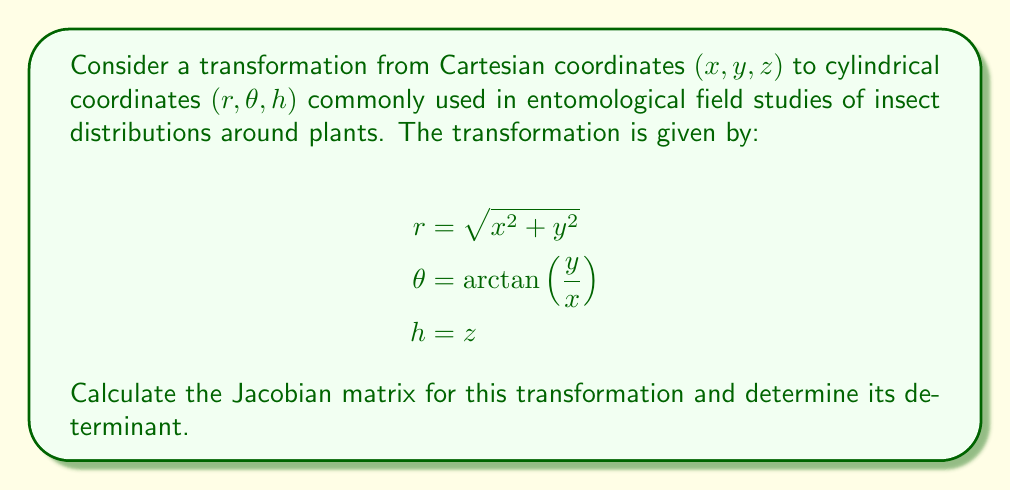Give your solution to this math problem. To solve this problem, we'll follow these steps:

1) First, we need to calculate the partial derivatives of each new coordinate $(r, \theta, h)$ with respect to each original coordinate $(x, y, z)$. These will form the elements of our Jacobian matrix.

2) For $r = \sqrt{x^2 + y^2}$:
   $$\frac{\partial r}{\partial x} = \frac{x}{\sqrt{x^2 + y^2}} = \frac{x}{r}$$
   $$\frac{\partial r}{\partial y} = \frac{y}{\sqrt{x^2 + y^2}} = \frac{y}{r}$$
   $$\frac{\partial r}{\partial z} = 0$$

3) For $\theta = \arctan\left(\frac{y}{x}\right)$:
   $$\frac{\partial \theta}{\partial x} = -\frac{y}{x^2 + y^2} = -\frac{y}{r^2}$$
   $$\frac{\partial \theta}{\partial y} = \frac{x}{x^2 + y^2} = \frac{x}{r^2}$$
   $$\frac{\partial \theta}{\partial z} = 0$$

4) For $h = z$:
   $$\frac{\partial h}{\partial x} = 0$$
   $$\frac{\partial h}{\partial y} = 0$$
   $$\frac{\partial h}{\partial z} = 1$$

5) Now we can form the Jacobian matrix:

   $$J = \begin{bmatrix}
   \frac{x}{r} & \frac{y}{r} & 0 \\
   -\frac{y}{r^2} & \frac{x}{r^2} & 0 \\
   0 & 0 & 1
   \end{bmatrix}$$

6) To find the determinant, we can use the first row expansion:

   $$\det(J) = \frac{x}{r} \cdot \begin{vmatrix}
   \frac{x}{r^2} & 0 \\
   0 & 1
   \end{vmatrix} - \frac{y}{r} \cdot \begin{vmatrix}
   -\frac{y}{r^2} & 0 \\
   0 & 1
   \end{vmatrix} + 0 \cdot \begin{vmatrix}
   -\frac{y}{r^2} & \frac{x}{r^2} \\
   0 & 0
   \end{vmatrix}$$

7) Simplifying:
   $$\det(J) = \frac{x}{r} \cdot \frac{x}{r^2} + \frac{y}{r} \cdot \frac{y}{r^2} = \frac{x^2 + y^2}{r^3} = \frac{r^2}{r^3} = \frac{1}{r}$$

Thus, the Jacobian determinant is $\frac{1}{r}$.
Answer: $J = \begin{bmatrix}
\frac{x}{r} & \frac{y}{r} & 0 \\
-\frac{y}{r^2} & \frac{x}{r^2} & 0 \\
0 & 0 & 1
\end{bmatrix}$, $\det(J) = \frac{1}{r}$ 